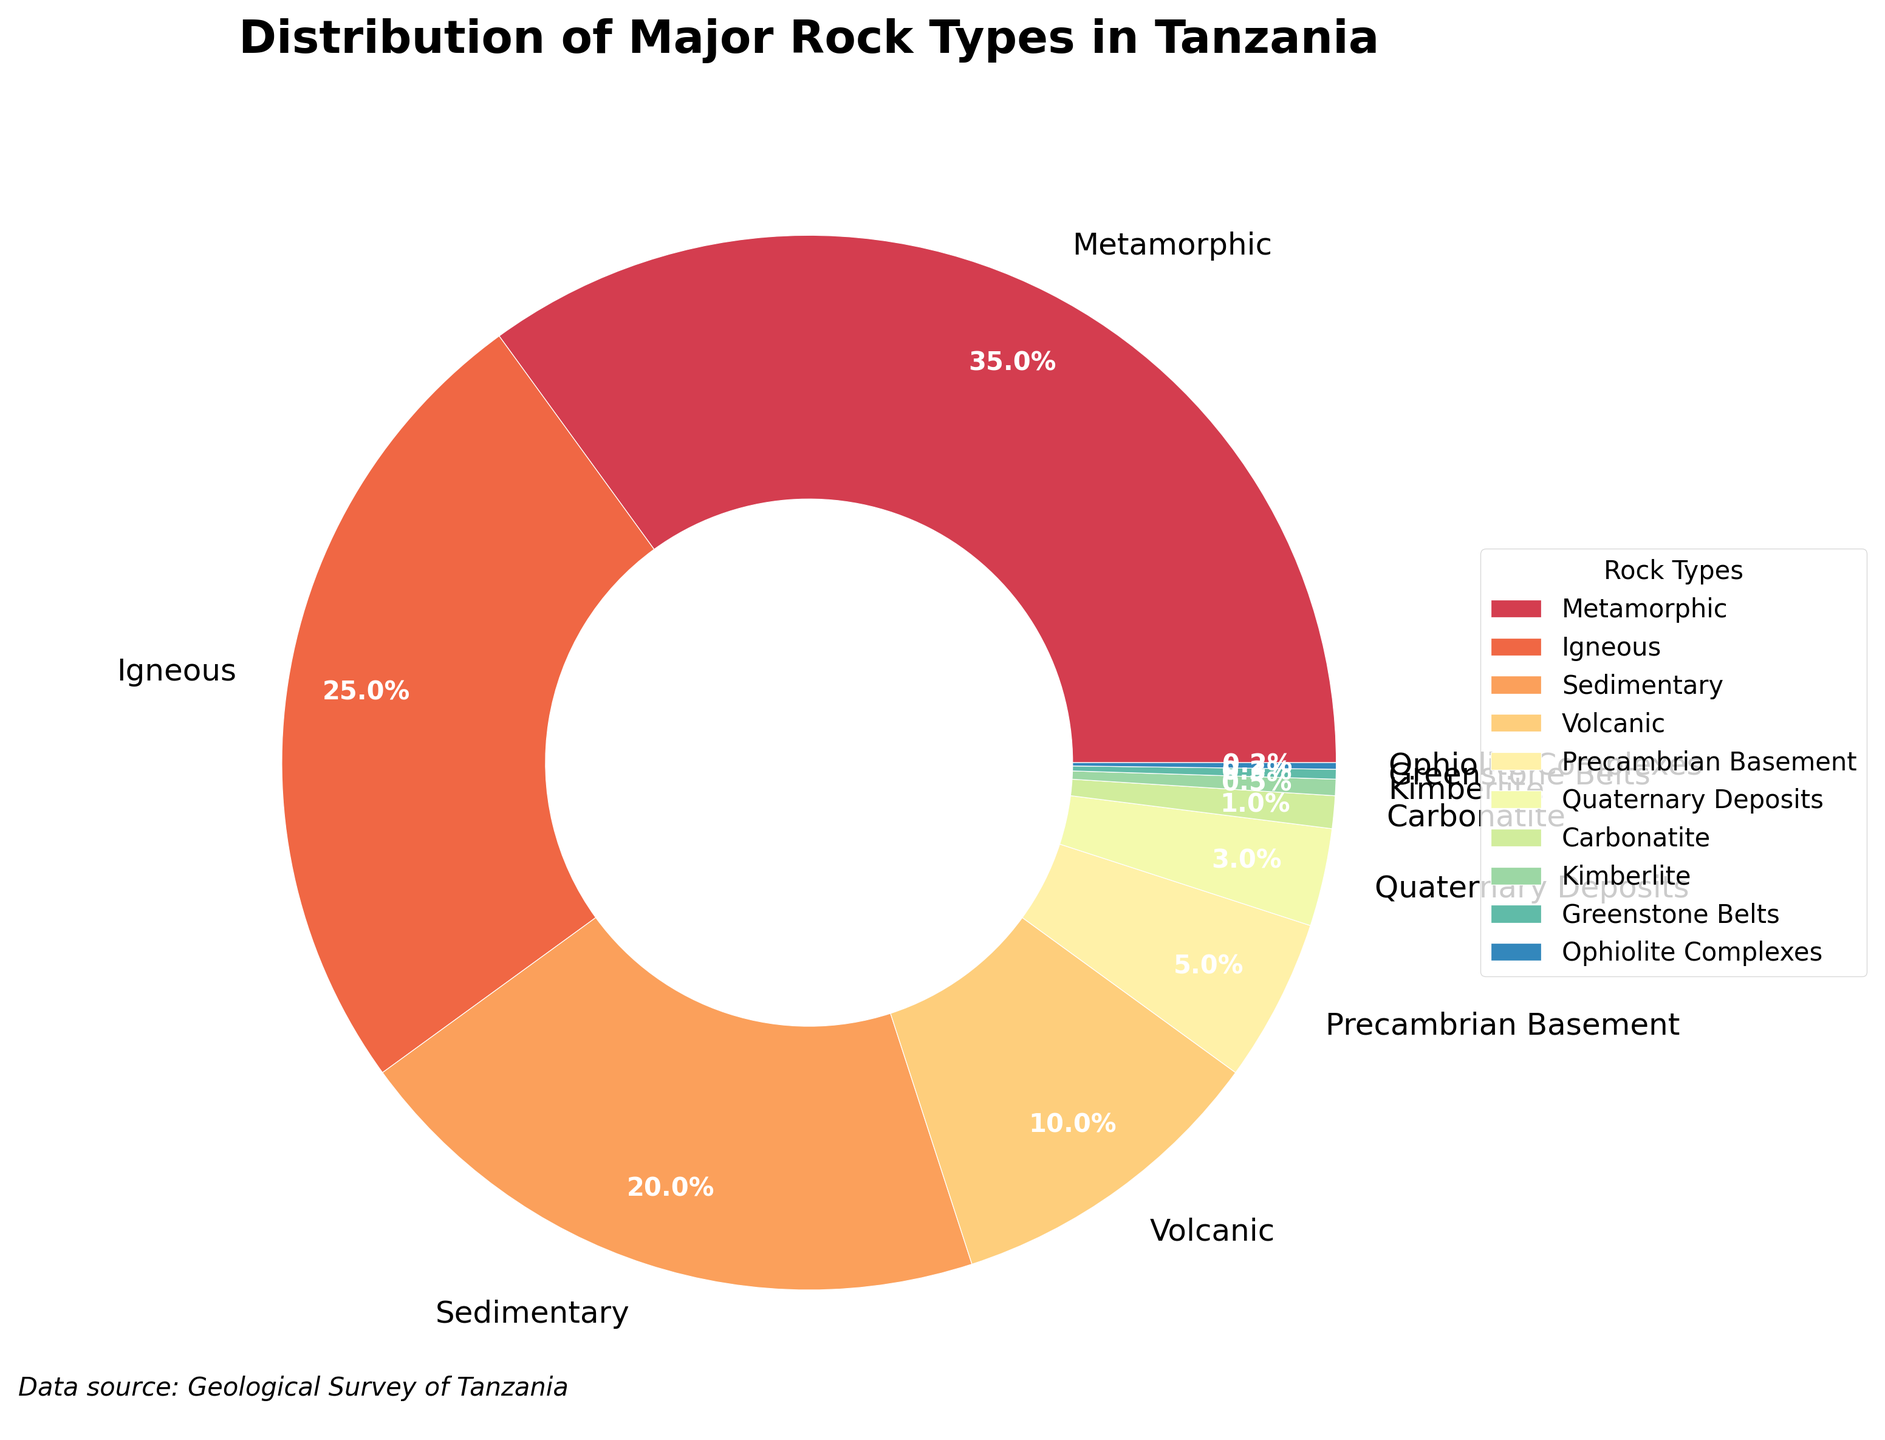What is the most abundant rock type in Tanzania according to the figure? The pie chart shows the distribution of various rock types in Tanzania, and the largest segment represents Metamorphic rocks. By observing the chart, we can see that Metamorphic rocks take up the largest portion.
Answer: Metamorphic What is the combined percentage of Igneous and Sedimentary rocks? To find the combined percentage of Igneous and Sedimentary rocks, add the individual percentages of Igneous (25%) and Sedimentary (20%).
Answer: 45% Which rock type has the smallest percentage, and what is its value? The smallest segment in the pie chart represents Kimberlite, which has the smallest numerical value. By checking the chart, we see that Kimberlite has the lowest percentage.
Answer: Kimberlite, 0.2% How does the percentage of Volcanic rocks compare to that of Precambrian Basement? The pie chart shows the percentages for both Volcanic (10%) and Precambrian Basement (5%) rock types. Volcanic rocks have a higher percentage than Precambrian Basement rocks.
Answer: Volcanic rocks have a higher percentage If you sum up the percentages of all rock types other than Metamorphic and Igneous, what do you get? Exclude Metamorphic (35%) and Igneous (25%), and sum up the remaining percentages: Sedimentary (20%) + Volcanic (10%) + Precambrian Basement (5%) + Quaternary Deposits (3%) + Carbonatite (1%) + Kimberlite (0.5%) + Greenstone Belts (0.3%) + Ophiolite Complexes (0.2%). The total is 20 + 10 + 5 + 3 + 1 + 0.5 + 0.3 + 0.2 = 40%.
Answer: 40% What is the difference in percentage between Sedimentary and Quaternary Deposits? The pie chart shows that Sedimentary rocks constitute 20% and Quaternary Deposits constitute 3%. The difference between these percentages is 20% - 3%.
Answer: 17% Is the percentage of Greenstone Belts higher or lower than Carbonatite? By how much? The pie chart shows Greenstone Belts at 0.3% and Carbonatite at 1%. To find the difference, subtract 0.3% from 1%.
Answer: Lower by 0.7% Which segment is visually the longest on the pie chart, and what percentage does it correspond to? The visual attribute that signifies the longest segment in the pie chart corresponds to Metamorphic, with the largest percentage. The longest segment represents the largest percentage.
Answer: Metamorphic, 35% What percentage of the total is represented by rocks other than the top three rock types? The top three rock types are Metamorphic (35%), Igneous (25%), and Sedimentary (20%). Their combined percentage is 35% + 25% + 20% = 80%. The total percentage for other rocks is 100% - 80%.
Answer: 20% 